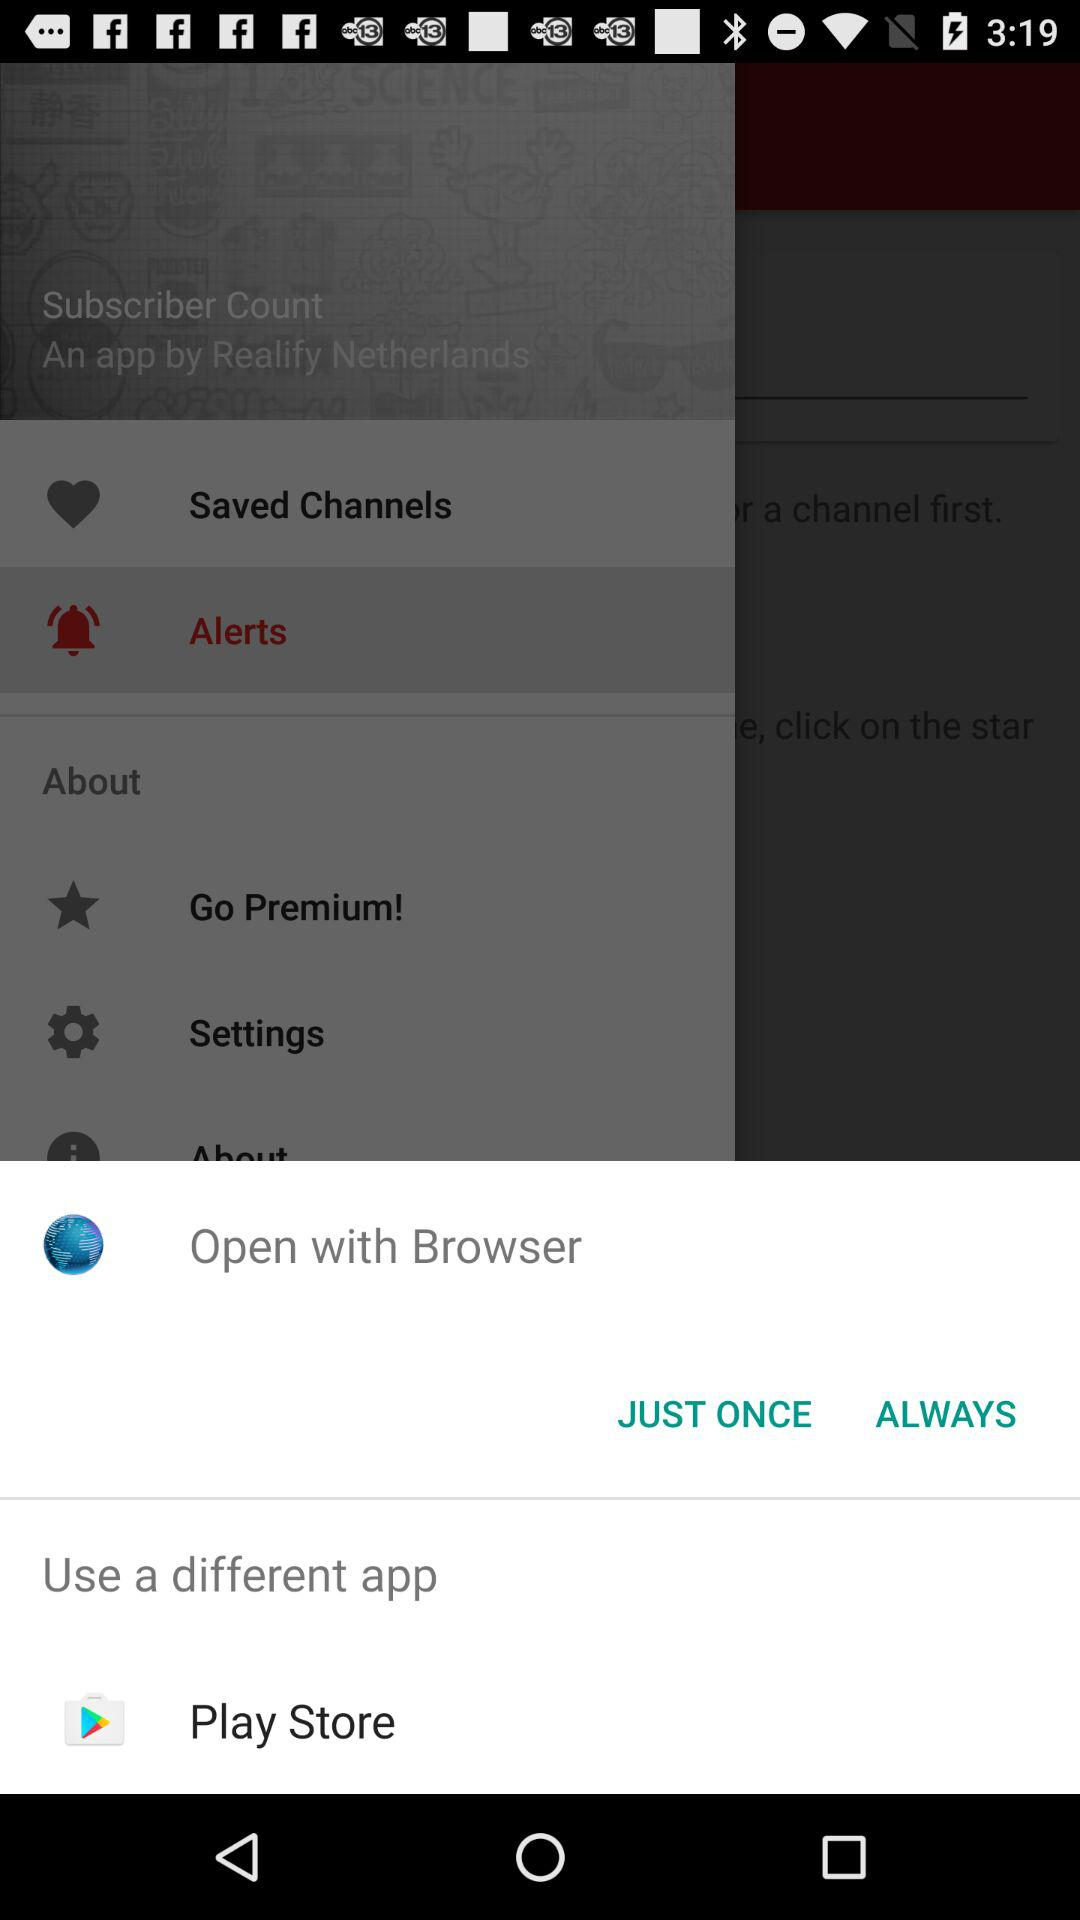Which item is selected? The selected item is "Alerts". 